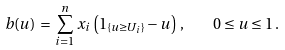Convert formula to latex. <formula><loc_0><loc_0><loc_500><loc_500>b ( u ) \, = \, \sum _ { i = 1 } ^ { n } x _ { i } \left ( { 1 } _ { \{ u \geq U _ { i } \} } - u \right ) \, , \quad 0 \leq u \leq 1 \, .</formula> 